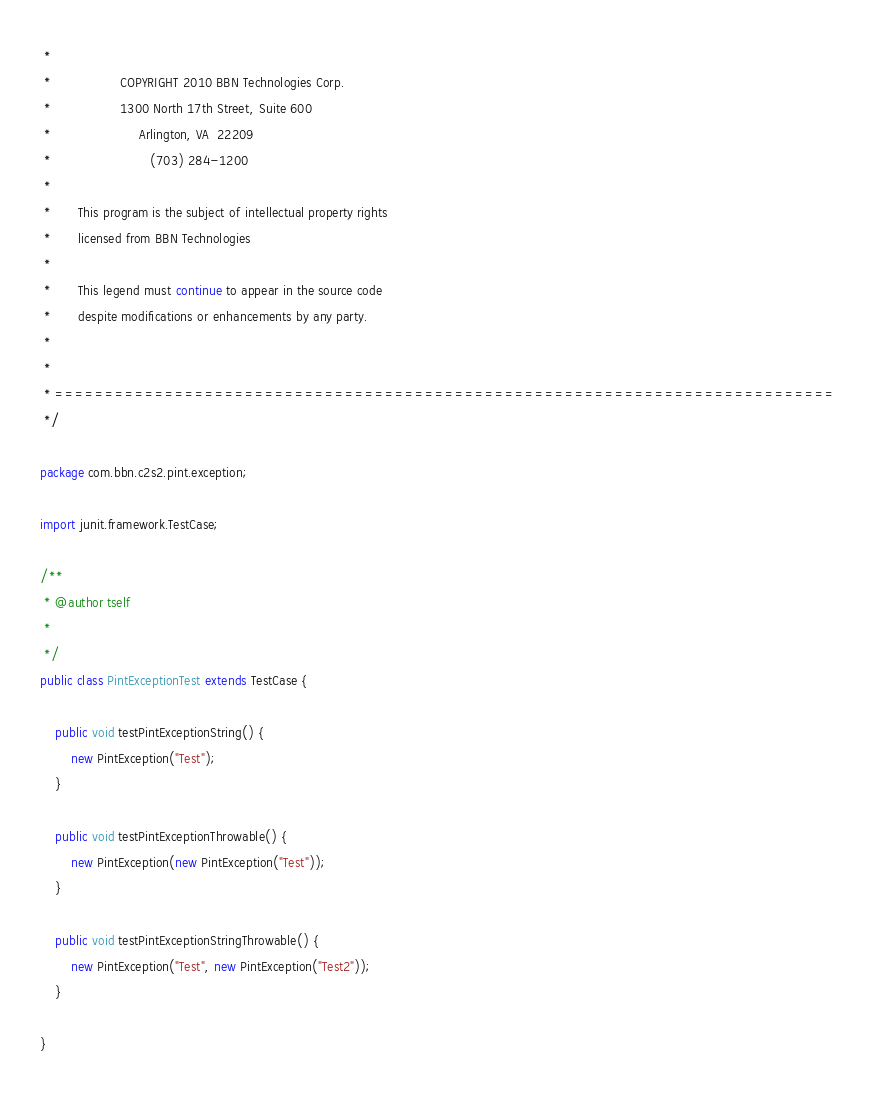<code> <loc_0><loc_0><loc_500><loc_500><_Java_> *
 *                  COPYRIGHT 2010 BBN Technologies Corp.
 *                  1300 North 17th Street, Suite 600
 *                       Arlington, VA  22209
 *                          (703) 284-1200
 *
 *       This program is the subject of intellectual property rights
 *       licensed from BBN Technologies
 *
 *       This legend must continue to appear in the source code
 *       despite modifications or enhancements by any party.
 *
 *
 * ==============================================================================
 */

package com.bbn.c2s2.pint.exception;

import junit.framework.TestCase;

/**
 * @author tself
 *
 */
public class PintExceptionTest extends TestCase {

	public void testPintExceptionString() {
		new PintException("Test");
	}

	public void testPintExceptionThrowable() {
		new PintException(new PintException("Test"));
	}

	public void testPintExceptionStringThrowable() {
		new PintException("Test", new PintException("Test2"));
	}

}
</code> 